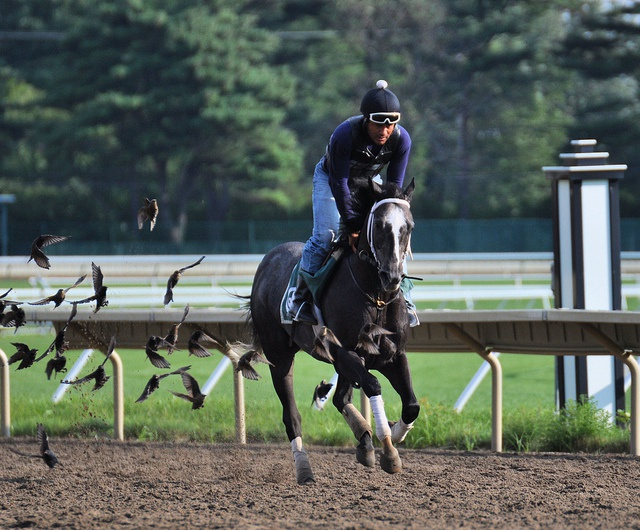Describe the objects in this image and their specific colors. I can see horse in darkblue, black, gray, darkgray, and lightgray tones, people in darkblue, black, gray, and navy tones, bird in darkblue, black, gray, and olive tones, bird in darkblue, olive, black, and gray tones, and bird in darkblue, black, gray, and olive tones in this image. 